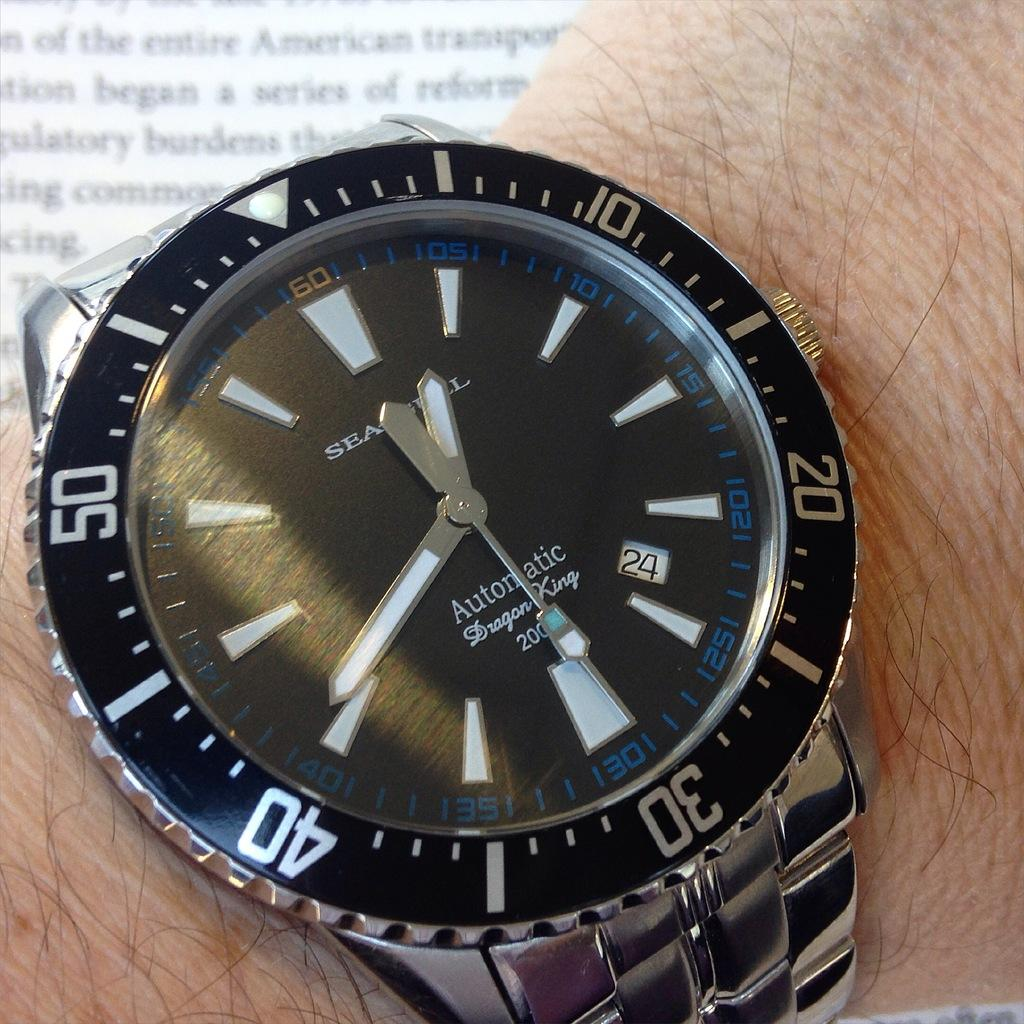<image>
Offer a succinct explanation of the picture presented. Inside the face of a watch shows the name Dragon King. 